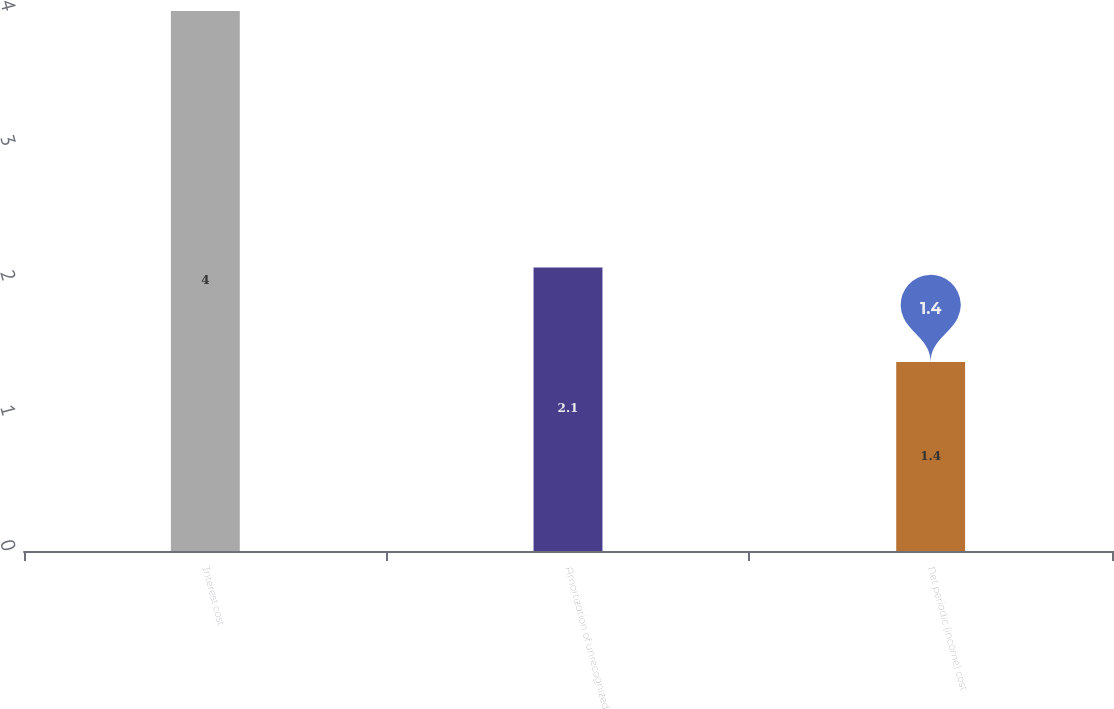Convert chart to OTSL. <chart><loc_0><loc_0><loc_500><loc_500><bar_chart><fcel>Interest cost<fcel>Amortization of unrecognized<fcel>Net periodic (income) cost<nl><fcel>4<fcel>2.1<fcel>1.4<nl></chart> 